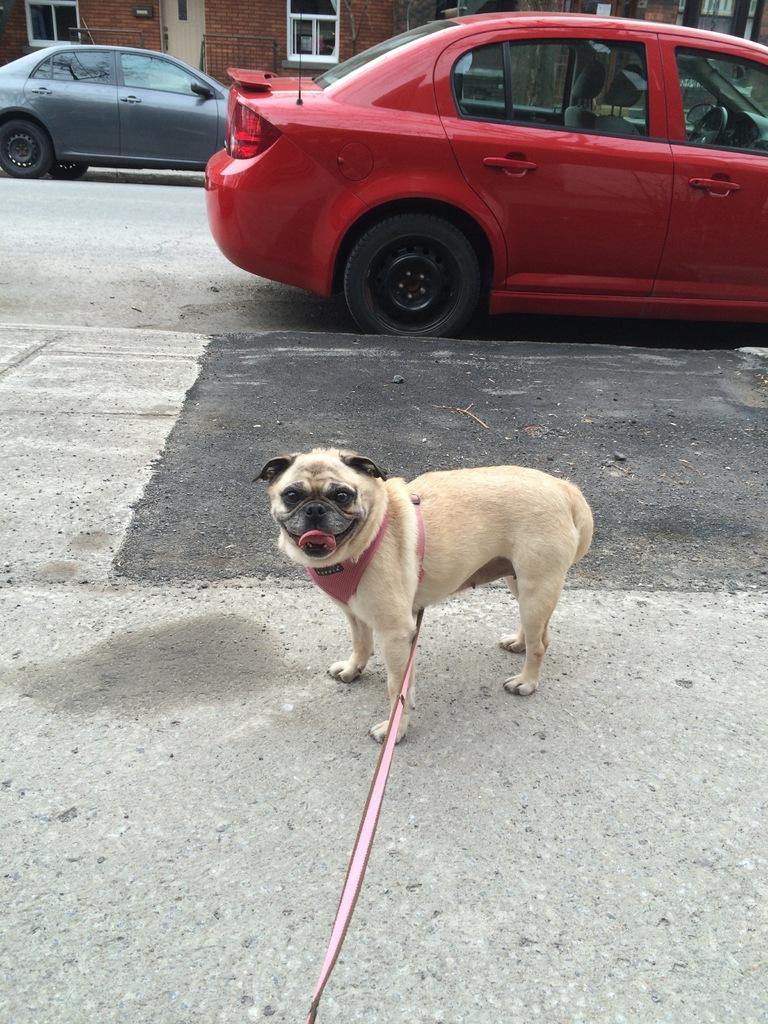How would you summarize this image in a sentence or two? In the foreground of the image we can see a road. In the middle of the image we can see a dog and a belt is there to a dog. On the top of the image we can see two cars. 